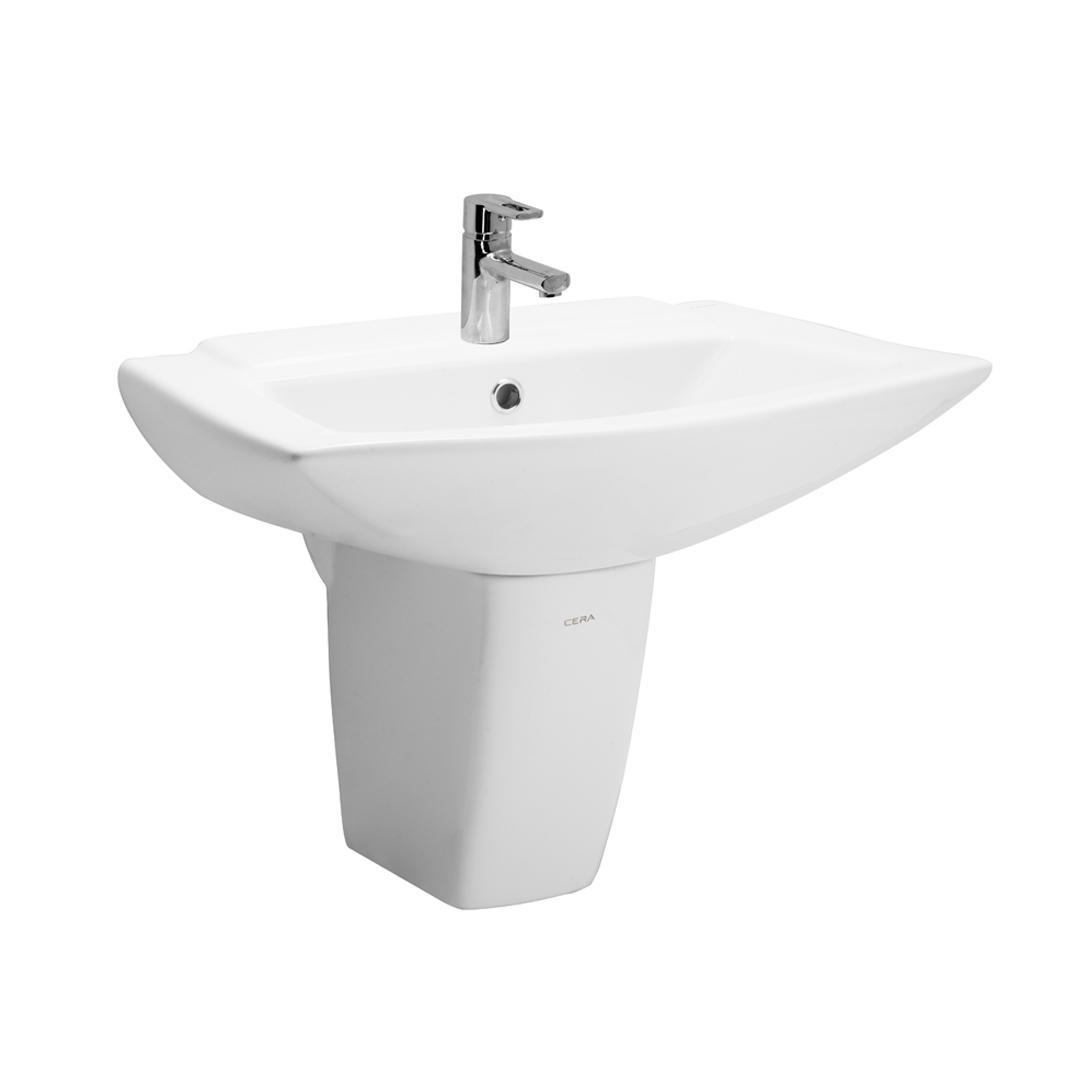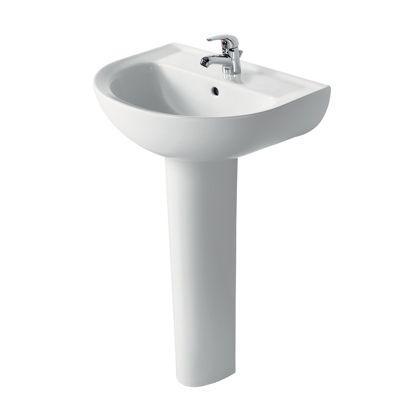The first image is the image on the left, the second image is the image on the right. Given the left and right images, does the statement "The drain in the bottom of the basin is visible in the image on the right." hold true? Answer yes or no. No. 